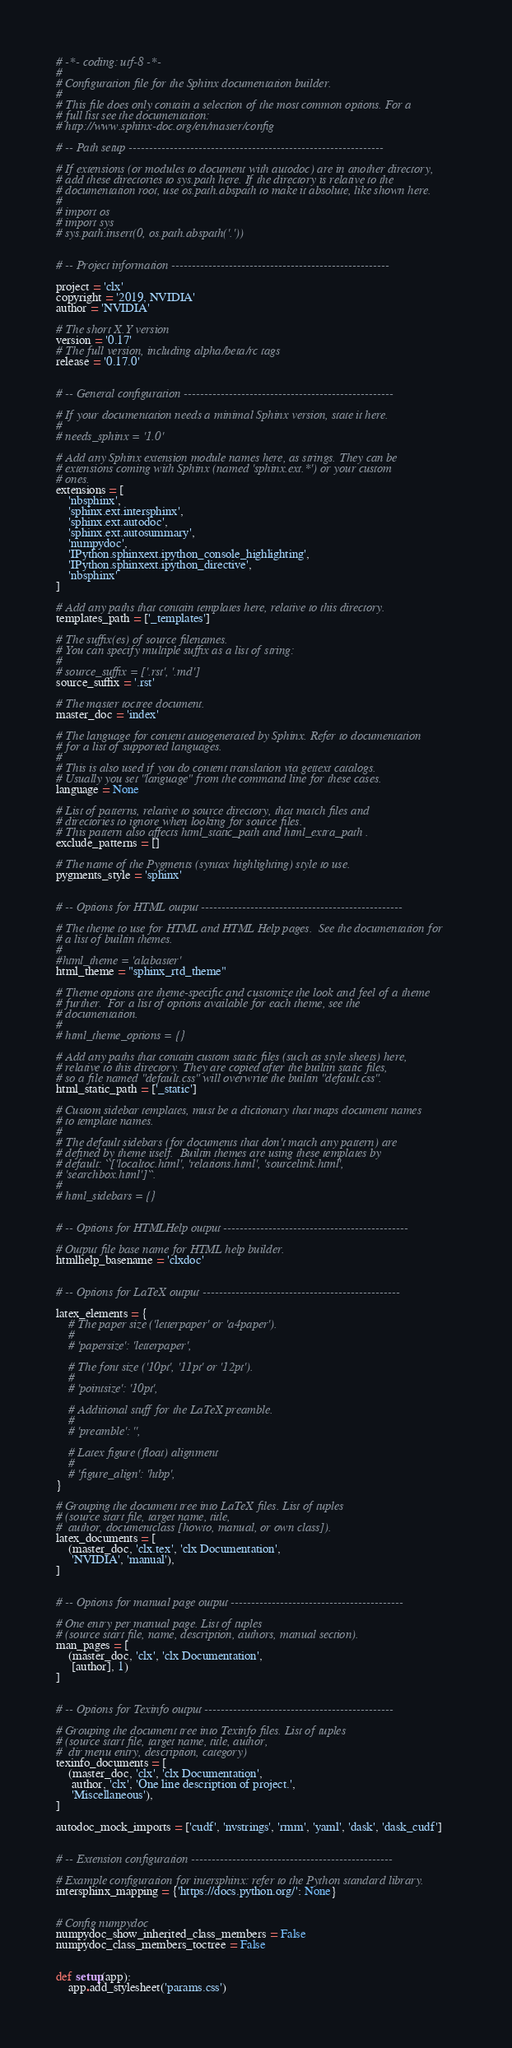<code> <loc_0><loc_0><loc_500><loc_500><_Python_># -*- coding: utf-8 -*-
#
# Configuration file for the Sphinx documentation builder.
#
# This file does only contain a selection of the most common options. For a
# full list see the documentation:
# http://www.sphinx-doc.org/en/master/config

# -- Path setup --------------------------------------------------------------

# If extensions (or modules to document with autodoc) are in another directory,
# add these directories to sys.path here. If the directory is relative to the
# documentation root, use os.path.abspath to make it absolute, like shown here.
#
# import os
# import sys
# sys.path.insert(0, os.path.abspath('.'))


# -- Project information -----------------------------------------------------

project = 'clx'
copyright = '2019, NVIDIA'
author = 'NVIDIA'

# The short X.Y version
version = '0.17'
# The full version, including alpha/beta/rc tags
release = '0.17.0'


# -- General configuration ---------------------------------------------------

# If your documentation needs a minimal Sphinx version, state it here.
#
# needs_sphinx = '1.0'

# Add any Sphinx extension module names here, as strings. They can be
# extensions coming with Sphinx (named 'sphinx.ext.*') or your custom
# ones.
extensions = [
    'nbsphinx',
    'sphinx.ext.intersphinx',
    'sphinx.ext.autodoc',
    'sphinx.ext.autosummary',
    'numpydoc',
    'IPython.sphinxext.ipython_console_highlighting',
    'IPython.sphinxext.ipython_directive',
    'nbsphinx'
]

# Add any paths that contain templates here, relative to this directory.
templates_path = ['_templates']

# The suffix(es) of source filenames.
# You can specify multiple suffix as a list of string:
#
# source_suffix = ['.rst', '.md']
source_suffix = '.rst'

# The master toctree document.
master_doc = 'index'

# The language for content autogenerated by Sphinx. Refer to documentation
# for a list of supported languages.
#
# This is also used if you do content translation via gettext catalogs.
# Usually you set "language" from the command line for these cases.
language = None

# List of patterns, relative to source directory, that match files and
# directories to ignore when looking for source files.
# This pattern also affects html_static_path and html_extra_path .
exclude_patterns = []

# The name of the Pygments (syntax highlighting) style to use.
pygments_style = 'sphinx'


# -- Options for HTML output -------------------------------------------------

# The theme to use for HTML and HTML Help pages.  See the documentation for
# a list of builtin themes.
#
#html_theme = 'alabaster'
html_theme = "sphinx_rtd_theme"

# Theme options are theme-specific and customize the look and feel of a theme
# further.  For a list of options available for each theme, see the
# documentation.
#
# html_theme_options = {}

# Add any paths that contain custom static files (such as style sheets) here,
# relative to this directory. They are copied after the builtin static files,
# so a file named "default.css" will overwrite the builtin "default.css".
html_static_path = ['_static']

# Custom sidebar templates, must be a dictionary that maps document names
# to template names.
#
# The default sidebars (for documents that don't match any pattern) are
# defined by theme itself.  Builtin themes are using these templates by
# default: ``['localtoc.html', 'relations.html', 'sourcelink.html',
# 'searchbox.html']``.
#
# html_sidebars = {}


# -- Options for HTMLHelp output ---------------------------------------------

# Output file base name for HTML help builder.
htmlhelp_basename = 'clxdoc'


# -- Options for LaTeX output ------------------------------------------------

latex_elements = {
    # The paper size ('letterpaper' or 'a4paper').
    #
    # 'papersize': 'letterpaper',

    # The font size ('10pt', '11pt' or '12pt').
    #
    # 'pointsize': '10pt',

    # Additional stuff for the LaTeX preamble.
    #
    # 'preamble': '',

    # Latex figure (float) alignment
    #
    # 'figure_align': 'htbp',
}

# Grouping the document tree into LaTeX files. List of tuples
# (source start file, target name, title,
#  author, documentclass [howto, manual, or own class]).
latex_documents = [
    (master_doc, 'clx.tex', 'clx Documentation',
     'NVIDIA', 'manual'),
]


# -- Options for manual page output ------------------------------------------

# One entry per manual page. List of tuples
# (source start file, name, description, authors, manual section).
man_pages = [
    (master_doc, 'clx', 'clx Documentation',
     [author], 1)
]


# -- Options for Texinfo output ----------------------------------------------

# Grouping the document tree into Texinfo files. List of tuples
# (source start file, target name, title, author,
#  dir menu entry, description, category)
texinfo_documents = [
    (master_doc, 'clx', 'clx Documentation',
     author, 'clx', 'One line description of project.',
     'Miscellaneous'),
]

autodoc_mock_imports = ['cudf', 'nvstrings', 'rmm', 'yaml', 'dask', 'dask_cudf']


# -- Extension configuration -------------------------------------------------

# Example configuration for intersphinx: refer to the Python standard library.
intersphinx_mapping = {'https://docs.python.org/': None}


# Config numpydoc
numpydoc_show_inherited_class_members = False
numpydoc_class_members_toctree = False


def setup(app):
    app.add_stylesheet('params.css')
</code> 